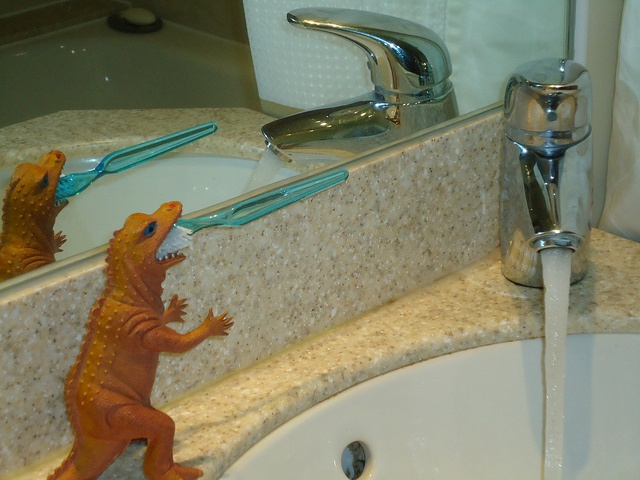Describe the objects in this image and their specific colors. I can see sink in black, gray, and darkgray tones, sink in black, darkgray, and gray tones, toothbrush in black and teal tones, and toothbrush in black, teal, and darkgreen tones in this image. 